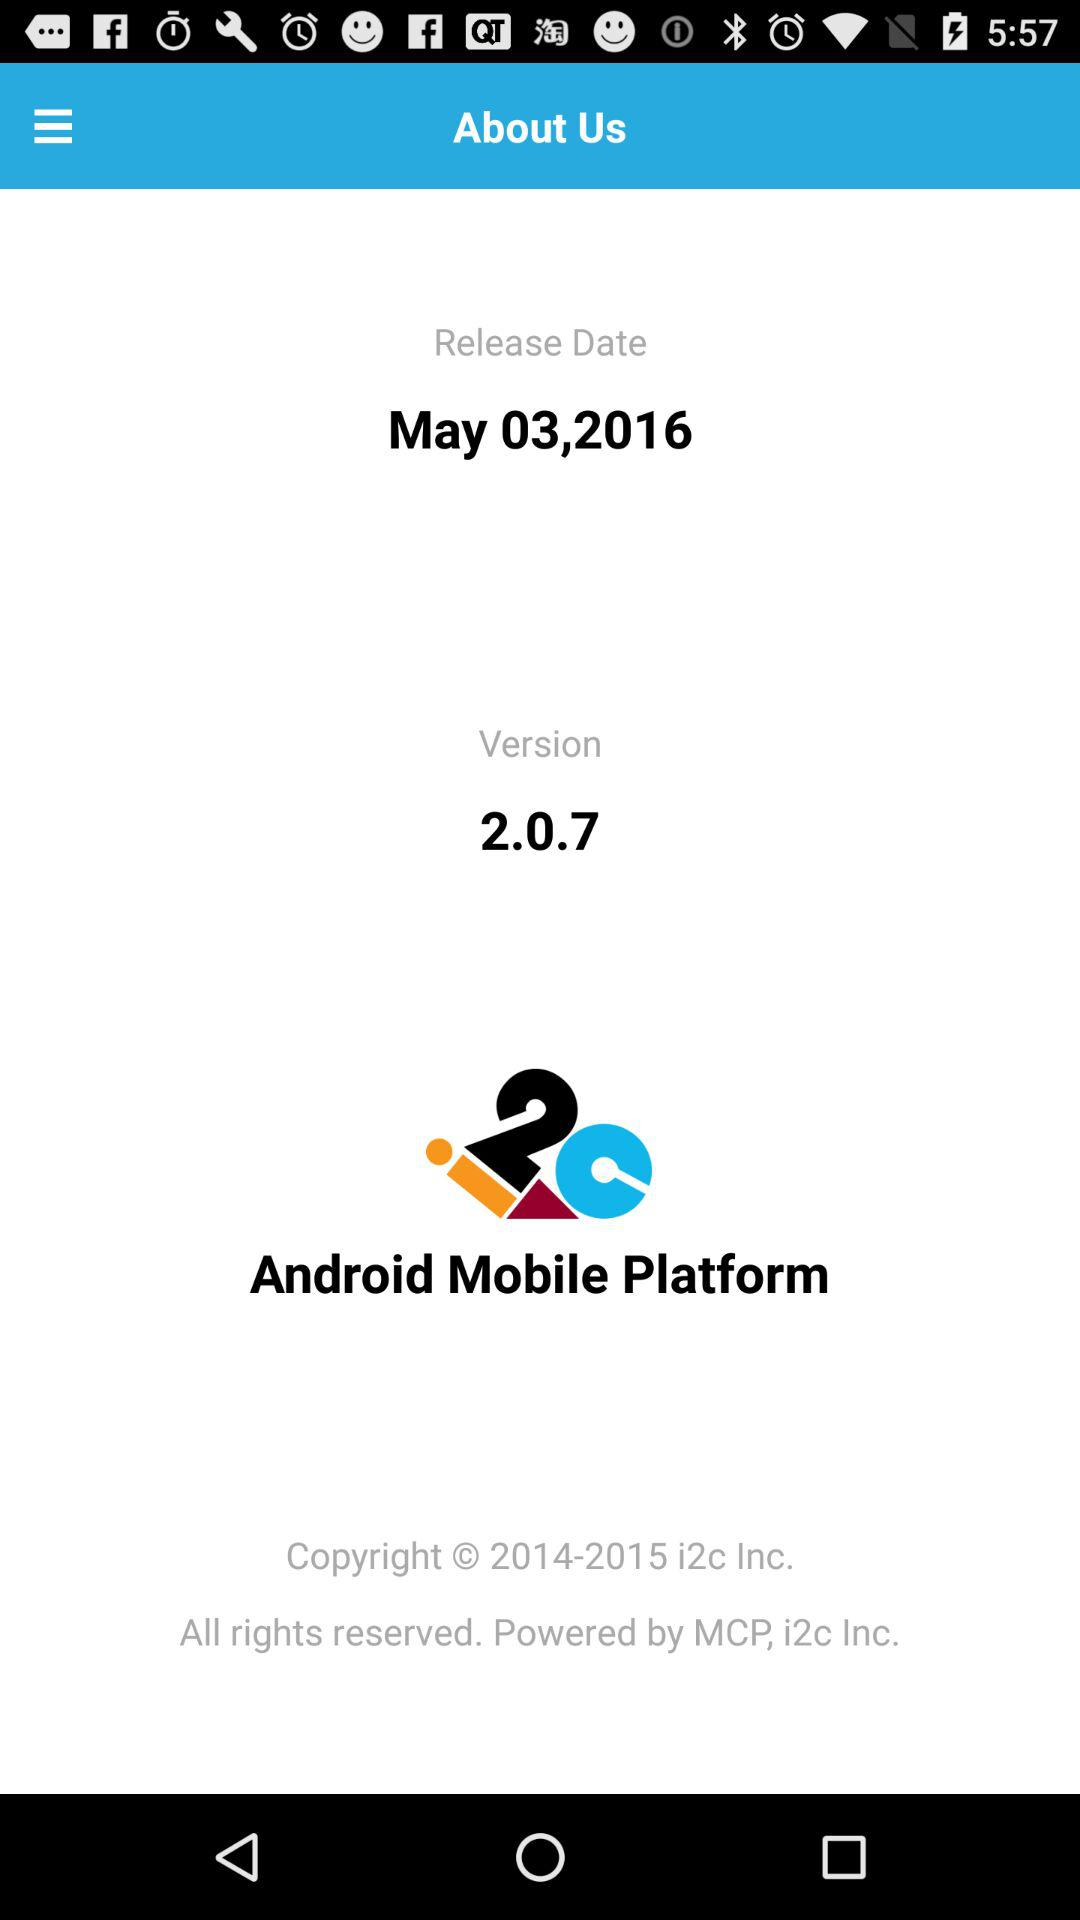What is the release date? The release date is May 3, 2016. 